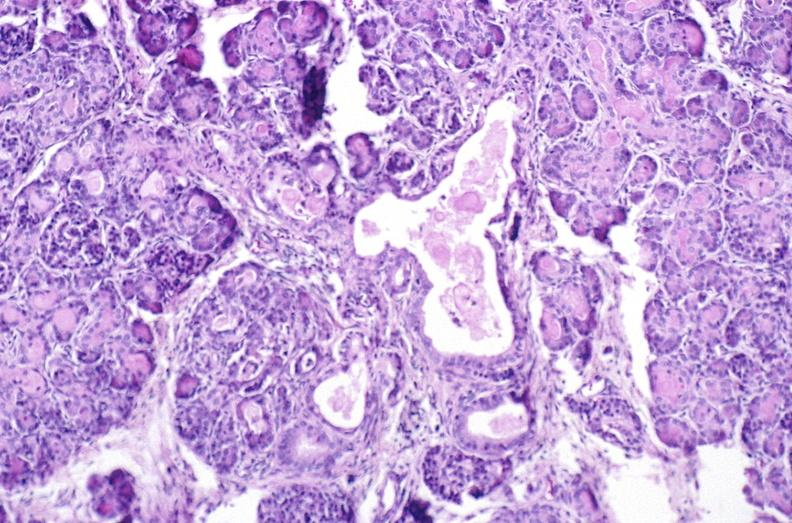does cephalohematoma show cystic fibrosis?
Answer the question using a single word or phrase. No 